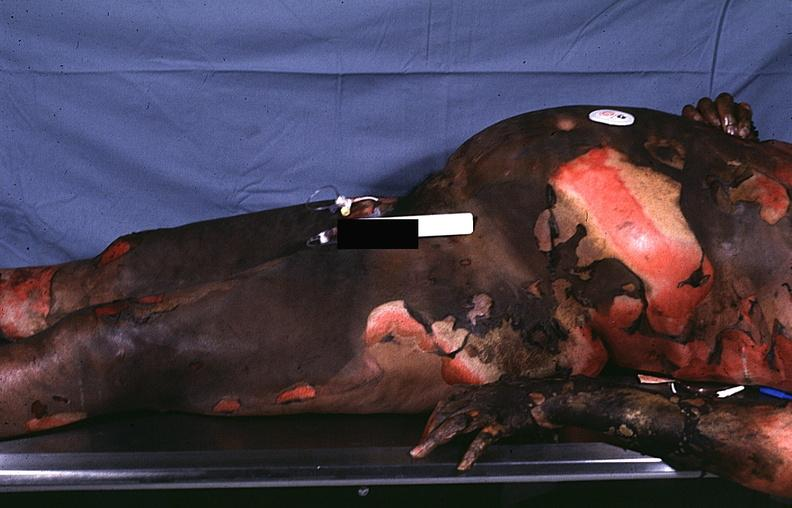does this image show thermal burn?
Answer the question using a single word or phrase. Yes 